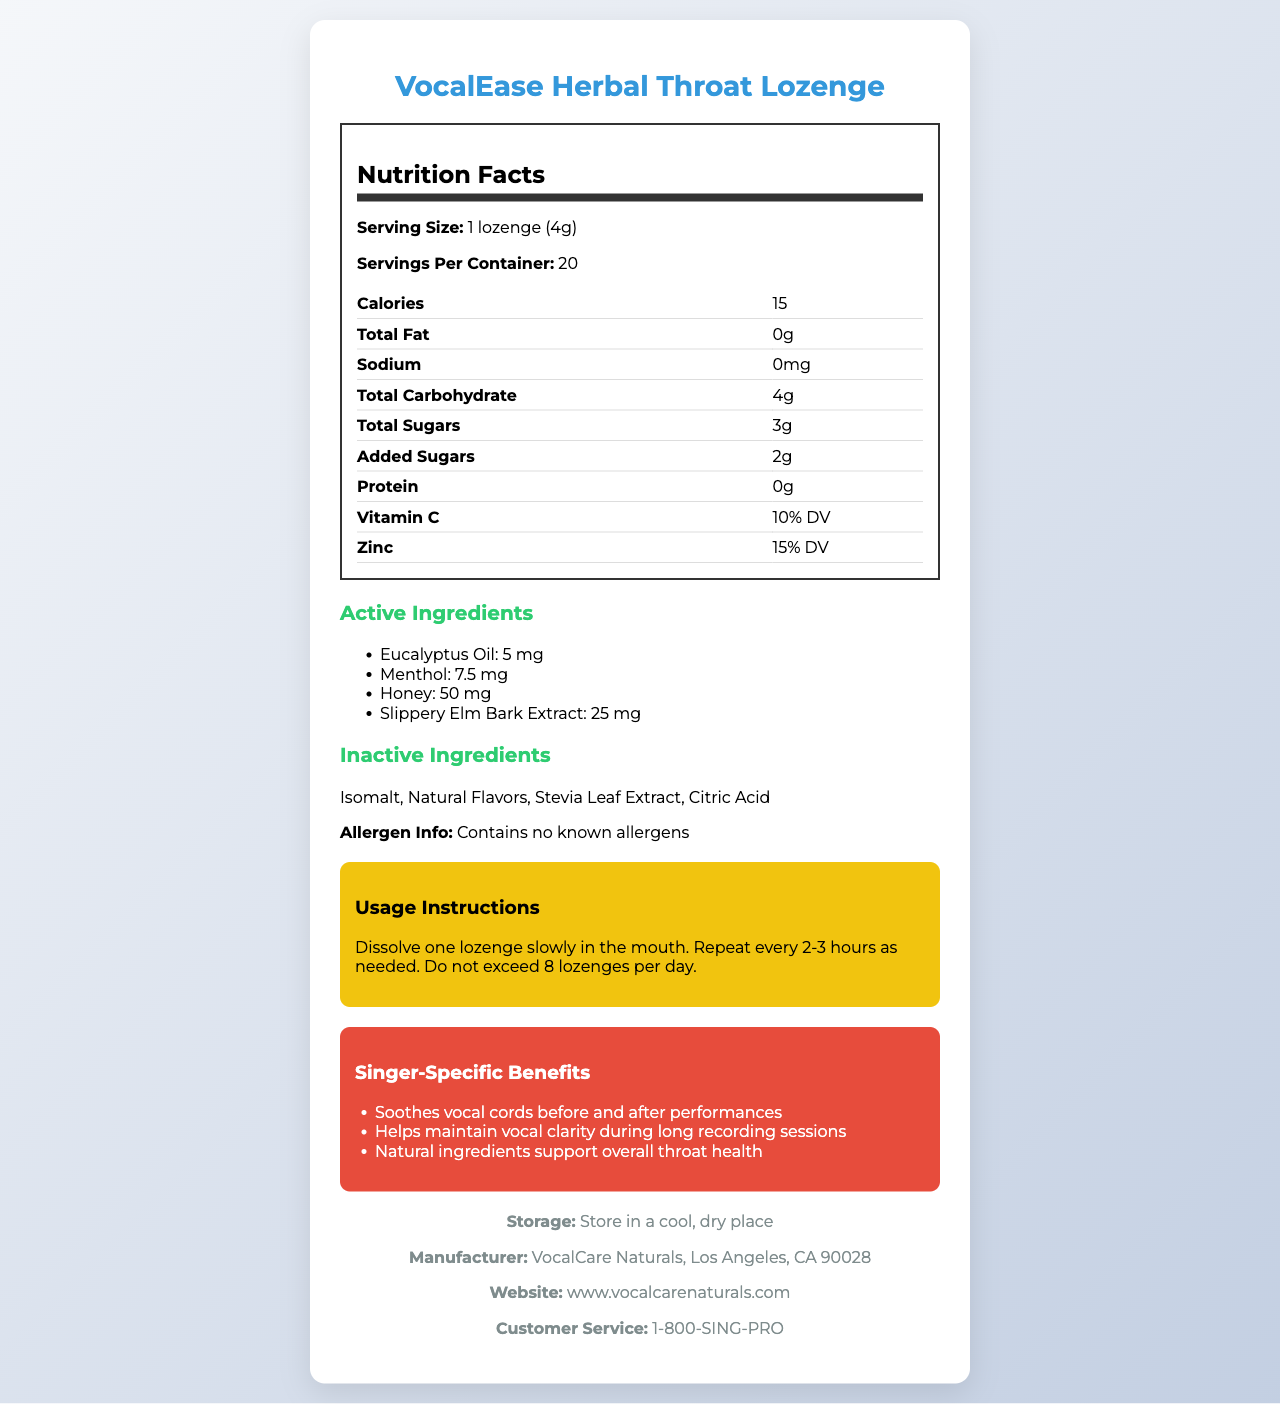what is the total carbohydrate content per serving? The document lists "Total Carbohydrate" as 4g under the nutrition facts section.
Answer: 4g how often should you take the lozenge? The usage instructions state to "Repeat every 2-3 hours as needed."
Answer: Every 2-3 hours as needed how many lozenges are in one container? The document states "Servings Per Container: 20."
Answer: 20 what is the amount of menthol in each lozenge? Under the active ingredients section, menthol is listed with an amount of 7.5 mg.
Answer: 7.5 mg what are the active ingredients? The active ingredients section lists these four ingredients.
Answer: Eucalyptus Oil, Menthol, Honey, Slippery Elm Bark Extract how many calories are in one lozenge? The nutrition facts section lists "Calories: 15."
Answer: 15 which vitamin is present in the lozenge? The nutrition facts section lists Vitamin C as 10% DV.
Answer: Vitamin C how many grams of added sugars are there per lozenge? The nutrition facts section lists "Added Sugars: 2g."
Answer: 2g how should the lozenges be stored? The storage instructions state to store the lozenges in a cool, dry place.
Answer: In a cool, dry place who manufactures the VocalEase Herbal Throat Lozenge? The footer lists the manufacturer as "VocalCare Naturals."
Answer: VocalCare Naturals how do the lozenges benefit singers? The singer-specific benefits section lists these three points.
Answer: Soothes vocal cords, maintains vocal clarity, supports throat health which of the following is NOT an active ingredient? A. Honey B. Menthol C. Citric Acid D. Slippery Elm Bark Extract The active ingredients listed are Eucalyptus Oil, Menthol, Honey, and Slippery Elm Bark Extract. Citric Acid is an inactive ingredient.
Answer: C. Citric Acid what percentage of the daily value of zinc does each lozenge provide? A. 10% B. 15% C. 20% D. 25% The nutrition facts section lists Zinc as providing 15% DV.
Answer: B. 15% does the product contain any known allergens? The allergic info section states "Contains no known allergens."
Answer: No is it safe to exceed 8 lozenges in one day? The usage instructions state "Do not exceed 8 lozenges per day."
Answer: No describe the main idea of the document The document includes a nutrition facts label, lists active and inactive ingredients, details usage instructions, highlights specific benefits for singers, and provides storage and manufacturing information.
Answer: The document provides detailed nutrition, ingredient, usage, and benefit information for the VocalEase Herbal Throat Lozenge, a product designed to soothe the throats of singers and maintain vocal health. what is the source of the natural flavors listed in the ingredients? The document lists "Natural Flavors" as an ingredient but does not specify their source.
Answer: Cannot be determined 